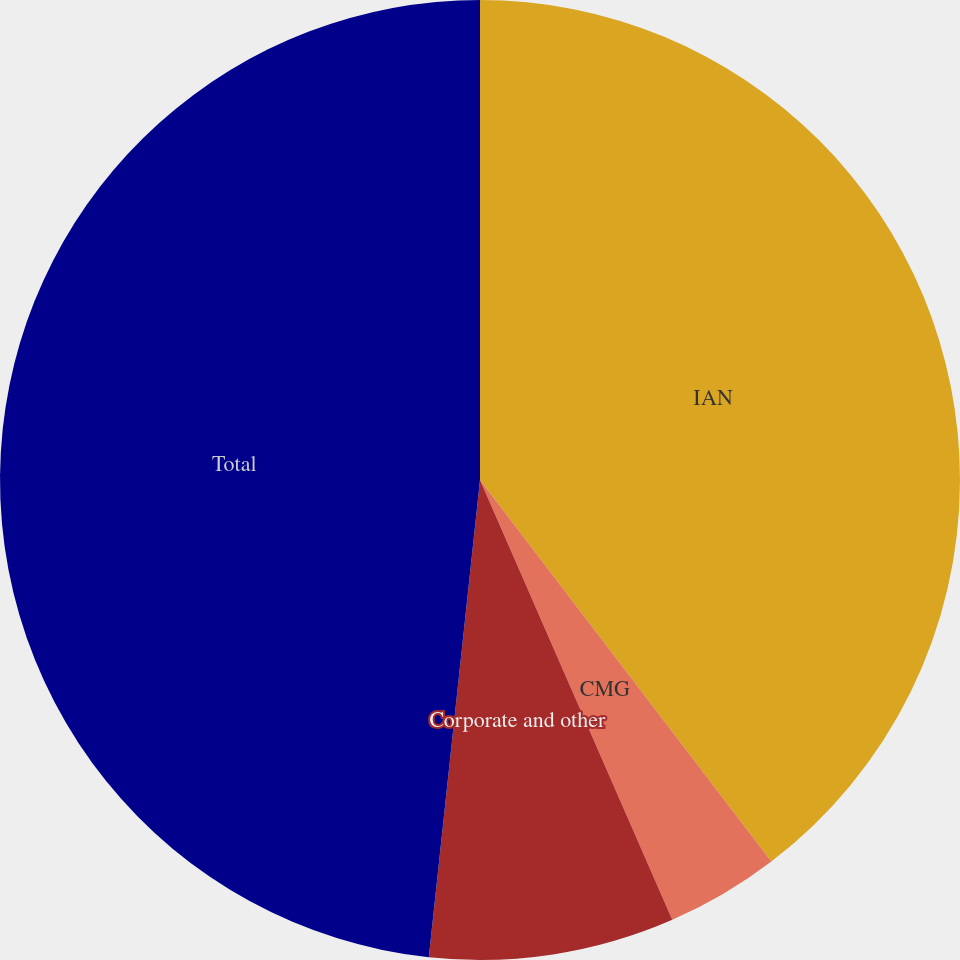Convert chart to OTSL. <chart><loc_0><loc_0><loc_500><loc_500><pie_chart><fcel>IAN<fcel>CMG<fcel>Corporate and other<fcel>Total<nl><fcel>39.62%<fcel>3.82%<fcel>8.26%<fcel>48.3%<nl></chart> 